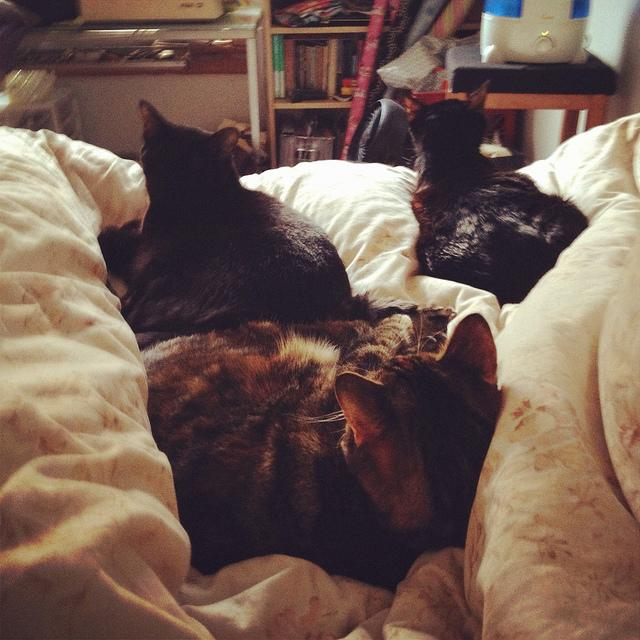What air quality problem occurs in this bedroom? low humidity 